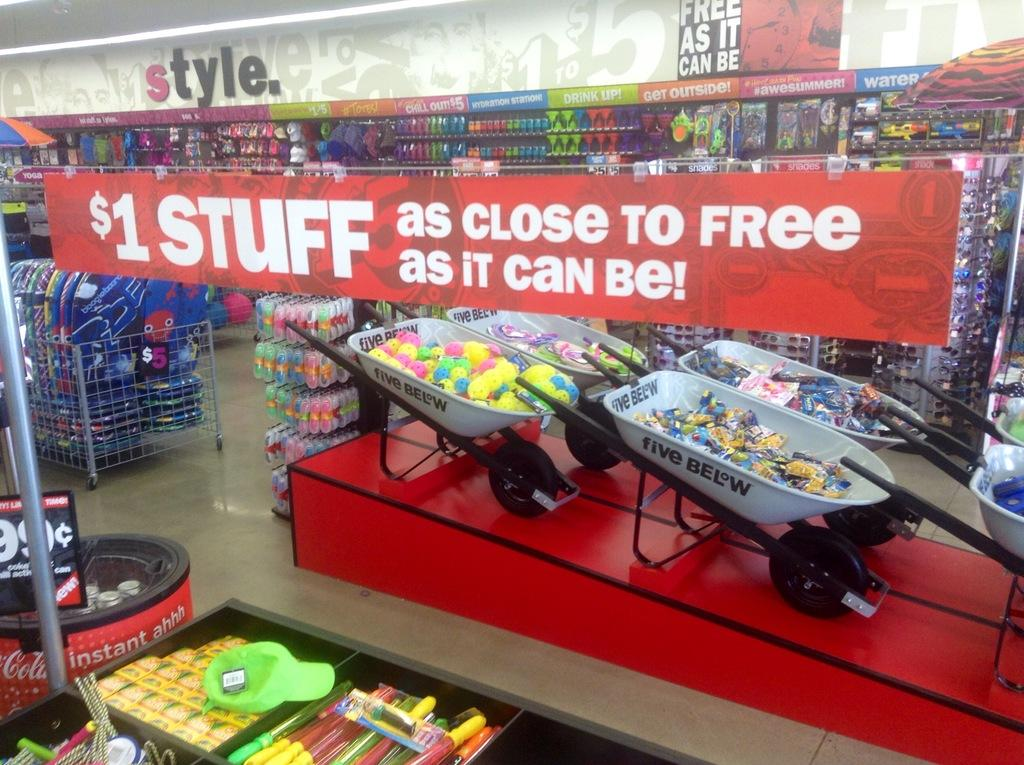Provide a one-sentence caption for the provided image. Many products on display below a sign saying "$1 Stuff.". 